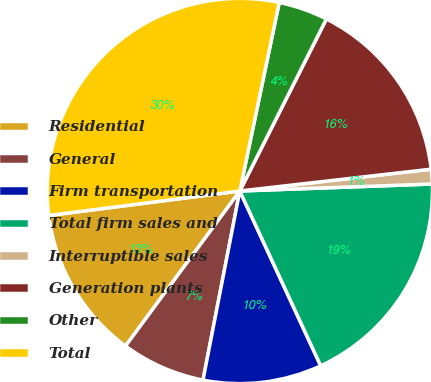Convert chart to OTSL. <chart><loc_0><loc_0><loc_500><loc_500><pie_chart><fcel>Residential<fcel>General<fcel>Firm transportation<fcel>Total firm sales and<fcel>Interruptible sales<fcel>Generation plants<fcel>Other<fcel>Total<nl><fcel>12.86%<fcel>7.05%<fcel>9.96%<fcel>18.68%<fcel>1.23%<fcel>15.77%<fcel>4.14%<fcel>30.31%<nl></chart> 